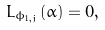<formula> <loc_0><loc_0><loc_500><loc_500>L _ { \phi _ { 1 , { j } } } ( \alpha ) = 0 ,</formula> 